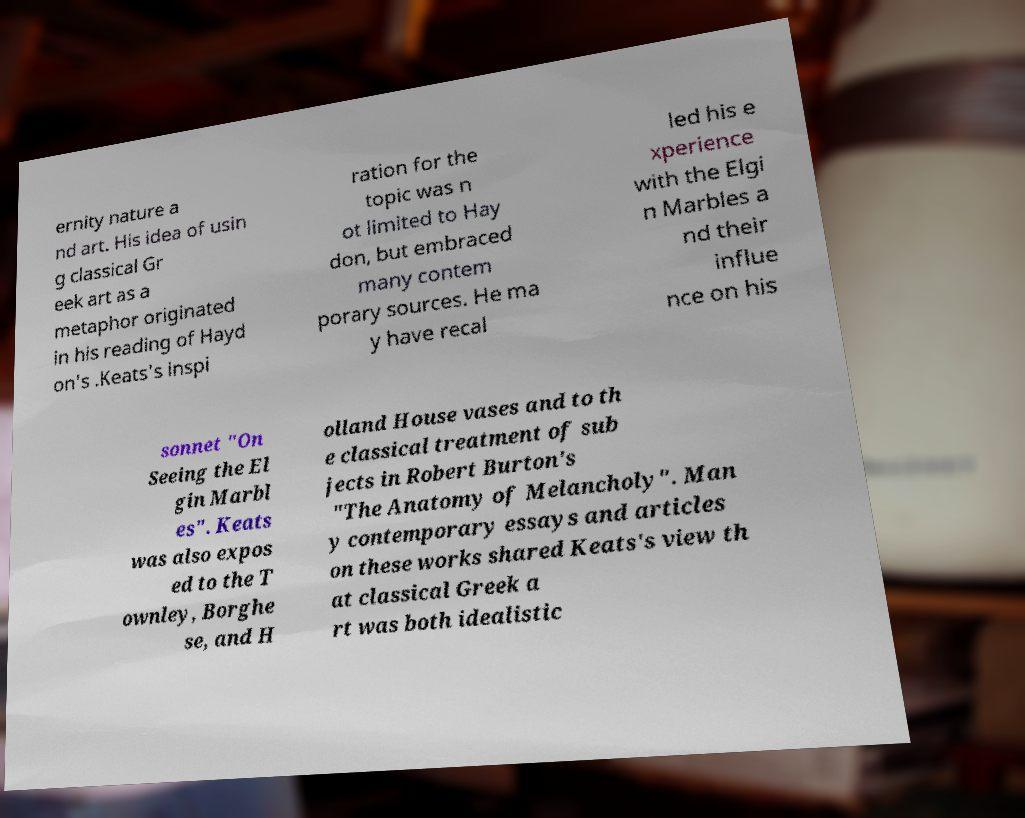Please identify and transcribe the text found in this image. ernity nature a nd art. His idea of usin g classical Gr eek art as a metaphor originated in his reading of Hayd on's .Keats's inspi ration for the topic was n ot limited to Hay don, but embraced many contem porary sources. He ma y have recal led his e xperience with the Elgi n Marbles a nd their influe nce on his sonnet "On Seeing the El gin Marbl es". Keats was also expos ed to the T ownley, Borghe se, and H olland House vases and to th e classical treatment of sub jects in Robert Burton's "The Anatomy of Melancholy". Man y contemporary essays and articles on these works shared Keats's view th at classical Greek a rt was both idealistic 